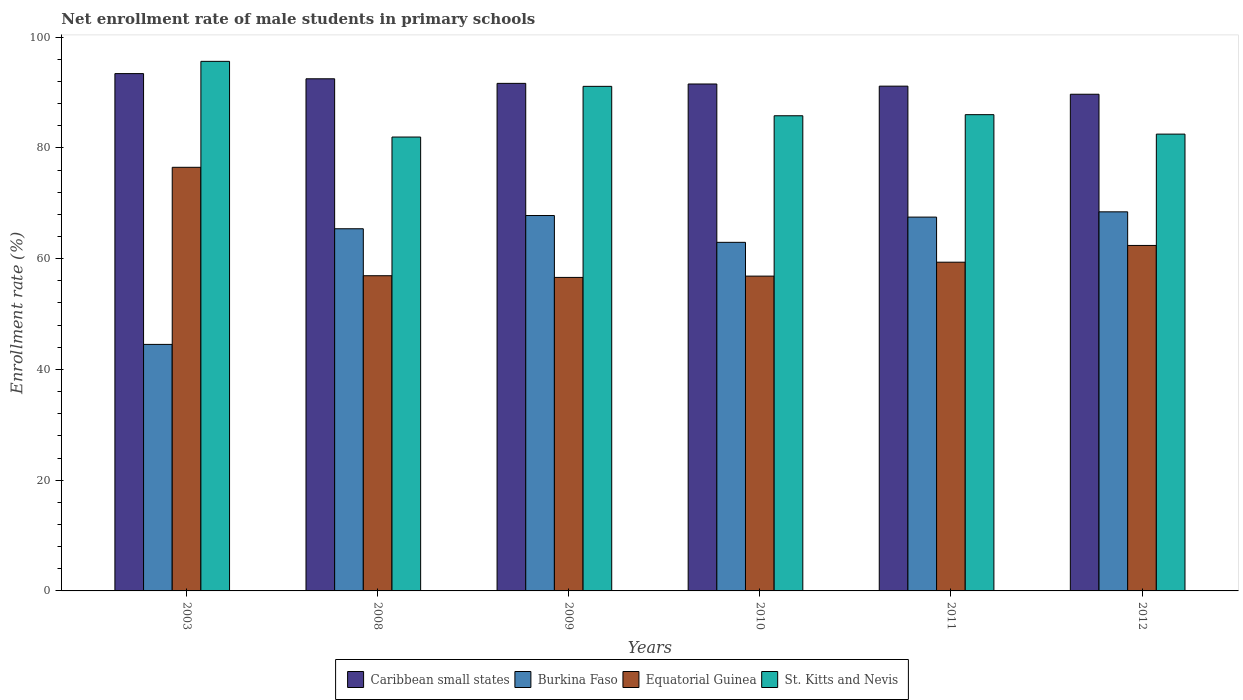How many groups of bars are there?
Offer a terse response. 6. Are the number of bars per tick equal to the number of legend labels?
Keep it short and to the point. Yes. How many bars are there on the 5th tick from the right?
Your answer should be compact. 4. What is the net enrollment rate of male students in primary schools in Caribbean small states in 2012?
Make the answer very short. 89.69. Across all years, what is the maximum net enrollment rate of male students in primary schools in Caribbean small states?
Keep it short and to the point. 93.42. Across all years, what is the minimum net enrollment rate of male students in primary schools in Burkina Faso?
Keep it short and to the point. 44.52. In which year was the net enrollment rate of male students in primary schools in Equatorial Guinea maximum?
Your response must be concise. 2003. In which year was the net enrollment rate of male students in primary schools in Caribbean small states minimum?
Offer a terse response. 2012. What is the total net enrollment rate of male students in primary schools in St. Kitts and Nevis in the graph?
Offer a terse response. 523. What is the difference between the net enrollment rate of male students in primary schools in Caribbean small states in 2003 and that in 2008?
Offer a very short reply. 0.94. What is the difference between the net enrollment rate of male students in primary schools in Caribbean small states in 2008 and the net enrollment rate of male students in primary schools in Burkina Faso in 2010?
Your answer should be very brief. 29.53. What is the average net enrollment rate of male students in primary schools in St. Kitts and Nevis per year?
Offer a terse response. 87.17. In the year 2009, what is the difference between the net enrollment rate of male students in primary schools in Equatorial Guinea and net enrollment rate of male students in primary schools in Caribbean small states?
Provide a short and direct response. -35.04. What is the ratio of the net enrollment rate of male students in primary schools in Caribbean small states in 2003 to that in 2010?
Offer a terse response. 1.02. Is the difference between the net enrollment rate of male students in primary schools in Equatorial Guinea in 2009 and 2012 greater than the difference between the net enrollment rate of male students in primary schools in Caribbean small states in 2009 and 2012?
Provide a succinct answer. No. What is the difference between the highest and the second highest net enrollment rate of male students in primary schools in Caribbean small states?
Your answer should be very brief. 0.94. What is the difference between the highest and the lowest net enrollment rate of male students in primary schools in Caribbean small states?
Your answer should be compact. 3.73. In how many years, is the net enrollment rate of male students in primary schools in Caribbean small states greater than the average net enrollment rate of male students in primary schools in Caribbean small states taken over all years?
Ensure brevity in your answer.  2. What does the 1st bar from the left in 2003 represents?
Ensure brevity in your answer.  Caribbean small states. What does the 1st bar from the right in 2012 represents?
Your response must be concise. St. Kitts and Nevis. Is it the case that in every year, the sum of the net enrollment rate of male students in primary schools in Caribbean small states and net enrollment rate of male students in primary schools in Burkina Faso is greater than the net enrollment rate of male students in primary schools in Equatorial Guinea?
Provide a succinct answer. Yes. Are all the bars in the graph horizontal?
Your answer should be compact. No. What is the difference between two consecutive major ticks on the Y-axis?
Keep it short and to the point. 20. Are the values on the major ticks of Y-axis written in scientific E-notation?
Keep it short and to the point. No. How many legend labels are there?
Provide a succinct answer. 4. How are the legend labels stacked?
Provide a succinct answer. Horizontal. What is the title of the graph?
Ensure brevity in your answer.  Net enrollment rate of male students in primary schools. Does "Belarus" appear as one of the legend labels in the graph?
Give a very brief answer. No. What is the label or title of the Y-axis?
Make the answer very short. Enrollment rate (%). What is the Enrollment rate (%) of Caribbean small states in 2003?
Offer a terse response. 93.42. What is the Enrollment rate (%) in Burkina Faso in 2003?
Provide a succinct answer. 44.52. What is the Enrollment rate (%) of Equatorial Guinea in 2003?
Your answer should be compact. 76.5. What is the Enrollment rate (%) in St. Kitts and Nevis in 2003?
Provide a succinct answer. 95.63. What is the Enrollment rate (%) of Caribbean small states in 2008?
Give a very brief answer. 92.48. What is the Enrollment rate (%) of Burkina Faso in 2008?
Give a very brief answer. 65.4. What is the Enrollment rate (%) in Equatorial Guinea in 2008?
Your answer should be compact. 56.92. What is the Enrollment rate (%) of St. Kitts and Nevis in 2008?
Provide a succinct answer. 81.96. What is the Enrollment rate (%) of Caribbean small states in 2009?
Provide a succinct answer. 91.65. What is the Enrollment rate (%) of Burkina Faso in 2009?
Provide a short and direct response. 67.79. What is the Enrollment rate (%) in Equatorial Guinea in 2009?
Offer a terse response. 56.61. What is the Enrollment rate (%) in St. Kitts and Nevis in 2009?
Give a very brief answer. 91.12. What is the Enrollment rate (%) of Caribbean small states in 2010?
Offer a terse response. 91.54. What is the Enrollment rate (%) of Burkina Faso in 2010?
Your answer should be compact. 62.95. What is the Enrollment rate (%) of Equatorial Guinea in 2010?
Provide a short and direct response. 56.85. What is the Enrollment rate (%) in St. Kitts and Nevis in 2010?
Offer a terse response. 85.8. What is the Enrollment rate (%) of Caribbean small states in 2011?
Your answer should be very brief. 91.15. What is the Enrollment rate (%) in Burkina Faso in 2011?
Keep it short and to the point. 67.5. What is the Enrollment rate (%) of Equatorial Guinea in 2011?
Offer a very short reply. 59.36. What is the Enrollment rate (%) of St. Kitts and Nevis in 2011?
Offer a very short reply. 86. What is the Enrollment rate (%) of Caribbean small states in 2012?
Ensure brevity in your answer.  89.69. What is the Enrollment rate (%) in Burkina Faso in 2012?
Offer a very short reply. 68.46. What is the Enrollment rate (%) in Equatorial Guinea in 2012?
Your response must be concise. 62.39. What is the Enrollment rate (%) in St. Kitts and Nevis in 2012?
Your answer should be compact. 82.49. Across all years, what is the maximum Enrollment rate (%) of Caribbean small states?
Your answer should be very brief. 93.42. Across all years, what is the maximum Enrollment rate (%) in Burkina Faso?
Ensure brevity in your answer.  68.46. Across all years, what is the maximum Enrollment rate (%) of Equatorial Guinea?
Provide a succinct answer. 76.5. Across all years, what is the maximum Enrollment rate (%) in St. Kitts and Nevis?
Your answer should be compact. 95.63. Across all years, what is the minimum Enrollment rate (%) of Caribbean small states?
Your answer should be very brief. 89.69. Across all years, what is the minimum Enrollment rate (%) of Burkina Faso?
Offer a very short reply. 44.52. Across all years, what is the minimum Enrollment rate (%) in Equatorial Guinea?
Your answer should be very brief. 56.61. Across all years, what is the minimum Enrollment rate (%) in St. Kitts and Nevis?
Offer a very short reply. 81.96. What is the total Enrollment rate (%) in Caribbean small states in the graph?
Make the answer very short. 549.93. What is the total Enrollment rate (%) of Burkina Faso in the graph?
Your answer should be very brief. 376.61. What is the total Enrollment rate (%) of Equatorial Guinea in the graph?
Keep it short and to the point. 368.62. What is the total Enrollment rate (%) of St. Kitts and Nevis in the graph?
Keep it short and to the point. 523. What is the difference between the Enrollment rate (%) in Caribbean small states in 2003 and that in 2008?
Offer a terse response. 0.94. What is the difference between the Enrollment rate (%) in Burkina Faso in 2003 and that in 2008?
Keep it short and to the point. -20.88. What is the difference between the Enrollment rate (%) of Equatorial Guinea in 2003 and that in 2008?
Your answer should be very brief. 19.58. What is the difference between the Enrollment rate (%) of St. Kitts and Nevis in 2003 and that in 2008?
Offer a very short reply. 13.67. What is the difference between the Enrollment rate (%) in Caribbean small states in 2003 and that in 2009?
Ensure brevity in your answer.  1.76. What is the difference between the Enrollment rate (%) in Burkina Faso in 2003 and that in 2009?
Ensure brevity in your answer.  -23.27. What is the difference between the Enrollment rate (%) in Equatorial Guinea in 2003 and that in 2009?
Your response must be concise. 19.89. What is the difference between the Enrollment rate (%) of St. Kitts and Nevis in 2003 and that in 2009?
Give a very brief answer. 4.51. What is the difference between the Enrollment rate (%) of Caribbean small states in 2003 and that in 2010?
Offer a terse response. 1.88. What is the difference between the Enrollment rate (%) of Burkina Faso in 2003 and that in 2010?
Your answer should be very brief. -18.43. What is the difference between the Enrollment rate (%) of Equatorial Guinea in 2003 and that in 2010?
Provide a succinct answer. 19.65. What is the difference between the Enrollment rate (%) of St. Kitts and Nevis in 2003 and that in 2010?
Your answer should be compact. 9.83. What is the difference between the Enrollment rate (%) of Caribbean small states in 2003 and that in 2011?
Your answer should be very brief. 2.27. What is the difference between the Enrollment rate (%) of Burkina Faso in 2003 and that in 2011?
Keep it short and to the point. -22.99. What is the difference between the Enrollment rate (%) of Equatorial Guinea in 2003 and that in 2011?
Offer a very short reply. 17.14. What is the difference between the Enrollment rate (%) in St. Kitts and Nevis in 2003 and that in 2011?
Your response must be concise. 9.63. What is the difference between the Enrollment rate (%) of Caribbean small states in 2003 and that in 2012?
Give a very brief answer. 3.73. What is the difference between the Enrollment rate (%) of Burkina Faso in 2003 and that in 2012?
Your answer should be compact. -23.94. What is the difference between the Enrollment rate (%) of Equatorial Guinea in 2003 and that in 2012?
Offer a terse response. 14.11. What is the difference between the Enrollment rate (%) of St. Kitts and Nevis in 2003 and that in 2012?
Offer a very short reply. 13.14. What is the difference between the Enrollment rate (%) of Caribbean small states in 2008 and that in 2009?
Keep it short and to the point. 0.83. What is the difference between the Enrollment rate (%) in Burkina Faso in 2008 and that in 2009?
Keep it short and to the point. -2.39. What is the difference between the Enrollment rate (%) of Equatorial Guinea in 2008 and that in 2009?
Ensure brevity in your answer.  0.31. What is the difference between the Enrollment rate (%) of St. Kitts and Nevis in 2008 and that in 2009?
Ensure brevity in your answer.  -9.15. What is the difference between the Enrollment rate (%) of Burkina Faso in 2008 and that in 2010?
Ensure brevity in your answer.  2.45. What is the difference between the Enrollment rate (%) of Equatorial Guinea in 2008 and that in 2010?
Give a very brief answer. 0.07. What is the difference between the Enrollment rate (%) of St. Kitts and Nevis in 2008 and that in 2010?
Your answer should be compact. -3.84. What is the difference between the Enrollment rate (%) in Caribbean small states in 2008 and that in 2011?
Your response must be concise. 1.33. What is the difference between the Enrollment rate (%) of Burkina Faso in 2008 and that in 2011?
Your answer should be very brief. -2.1. What is the difference between the Enrollment rate (%) of Equatorial Guinea in 2008 and that in 2011?
Offer a terse response. -2.44. What is the difference between the Enrollment rate (%) of St. Kitts and Nevis in 2008 and that in 2011?
Offer a terse response. -4.04. What is the difference between the Enrollment rate (%) in Caribbean small states in 2008 and that in 2012?
Offer a very short reply. 2.79. What is the difference between the Enrollment rate (%) of Burkina Faso in 2008 and that in 2012?
Offer a very short reply. -3.06. What is the difference between the Enrollment rate (%) in Equatorial Guinea in 2008 and that in 2012?
Make the answer very short. -5.47. What is the difference between the Enrollment rate (%) in St. Kitts and Nevis in 2008 and that in 2012?
Keep it short and to the point. -0.53. What is the difference between the Enrollment rate (%) in Caribbean small states in 2009 and that in 2010?
Give a very brief answer. 0.11. What is the difference between the Enrollment rate (%) in Burkina Faso in 2009 and that in 2010?
Offer a very short reply. 4.84. What is the difference between the Enrollment rate (%) in Equatorial Guinea in 2009 and that in 2010?
Ensure brevity in your answer.  -0.23. What is the difference between the Enrollment rate (%) of St. Kitts and Nevis in 2009 and that in 2010?
Provide a short and direct response. 5.31. What is the difference between the Enrollment rate (%) of Caribbean small states in 2009 and that in 2011?
Your response must be concise. 0.5. What is the difference between the Enrollment rate (%) in Burkina Faso in 2009 and that in 2011?
Provide a succinct answer. 0.28. What is the difference between the Enrollment rate (%) of Equatorial Guinea in 2009 and that in 2011?
Give a very brief answer. -2.75. What is the difference between the Enrollment rate (%) in St. Kitts and Nevis in 2009 and that in 2011?
Provide a short and direct response. 5.11. What is the difference between the Enrollment rate (%) of Caribbean small states in 2009 and that in 2012?
Your answer should be very brief. 1.96. What is the difference between the Enrollment rate (%) of Burkina Faso in 2009 and that in 2012?
Provide a short and direct response. -0.67. What is the difference between the Enrollment rate (%) in Equatorial Guinea in 2009 and that in 2012?
Keep it short and to the point. -5.77. What is the difference between the Enrollment rate (%) of St. Kitts and Nevis in 2009 and that in 2012?
Make the answer very short. 8.63. What is the difference between the Enrollment rate (%) in Caribbean small states in 2010 and that in 2011?
Your response must be concise. 0.39. What is the difference between the Enrollment rate (%) of Burkina Faso in 2010 and that in 2011?
Provide a succinct answer. -4.56. What is the difference between the Enrollment rate (%) in Equatorial Guinea in 2010 and that in 2011?
Offer a terse response. -2.52. What is the difference between the Enrollment rate (%) of St. Kitts and Nevis in 2010 and that in 2011?
Provide a short and direct response. -0.2. What is the difference between the Enrollment rate (%) in Caribbean small states in 2010 and that in 2012?
Offer a terse response. 1.85. What is the difference between the Enrollment rate (%) of Burkina Faso in 2010 and that in 2012?
Your answer should be compact. -5.51. What is the difference between the Enrollment rate (%) in Equatorial Guinea in 2010 and that in 2012?
Provide a succinct answer. -5.54. What is the difference between the Enrollment rate (%) in St. Kitts and Nevis in 2010 and that in 2012?
Make the answer very short. 3.31. What is the difference between the Enrollment rate (%) of Caribbean small states in 2011 and that in 2012?
Provide a short and direct response. 1.46. What is the difference between the Enrollment rate (%) of Burkina Faso in 2011 and that in 2012?
Give a very brief answer. -0.95. What is the difference between the Enrollment rate (%) of Equatorial Guinea in 2011 and that in 2012?
Ensure brevity in your answer.  -3.02. What is the difference between the Enrollment rate (%) in St. Kitts and Nevis in 2011 and that in 2012?
Your response must be concise. 3.51. What is the difference between the Enrollment rate (%) in Caribbean small states in 2003 and the Enrollment rate (%) in Burkina Faso in 2008?
Make the answer very short. 28.02. What is the difference between the Enrollment rate (%) of Caribbean small states in 2003 and the Enrollment rate (%) of Equatorial Guinea in 2008?
Provide a short and direct response. 36.5. What is the difference between the Enrollment rate (%) in Caribbean small states in 2003 and the Enrollment rate (%) in St. Kitts and Nevis in 2008?
Keep it short and to the point. 11.46. What is the difference between the Enrollment rate (%) in Burkina Faso in 2003 and the Enrollment rate (%) in Equatorial Guinea in 2008?
Give a very brief answer. -12.4. What is the difference between the Enrollment rate (%) in Burkina Faso in 2003 and the Enrollment rate (%) in St. Kitts and Nevis in 2008?
Your answer should be compact. -37.44. What is the difference between the Enrollment rate (%) in Equatorial Guinea in 2003 and the Enrollment rate (%) in St. Kitts and Nevis in 2008?
Your response must be concise. -5.46. What is the difference between the Enrollment rate (%) of Caribbean small states in 2003 and the Enrollment rate (%) of Burkina Faso in 2009?
Ensure brevity in your answer.  25.63. What is the difference between the Enrollment rate (%) in Caribbean small states in 2003 and the Enrollment rate (%) in Equatorial Guinea in 2009?
Your answer should be compact. 36.81. What is the difference between the Enrollment rate (%) in Caribbean small states in 2003 and the Enrollment rate (%) in St. Kitts and Nevis in 2009?
Provide a succinct answer. 2.3. What is the difference between the Enrollment rate (%) in Burkina Faso in 2003 and the Enrollment rate (%) in Equatorial Guinea in 2009?
Ensure brevity in your answer.  -12.1. What is the difference between the Enrollment rate (%) of Burkina Faso in 2003 and the Enrollment rate (%) of St. Kitts and Nevis in 2009?
Provide a succinct answer. -46.6. What is the difference between the Enrollment rate (%) in Equatorial Guinea in 2003 and the Enrollment rate (%) in St. Kitts and Nevis in 2009?
Offer a very short reply. -14.62. What is the difference between the Enrollment rate (%) in Caribbean small states in 2003 and the Enrollment rate (%) in Burkina Faso in 2010?
Provide a short and direct response. 30.47. What is the difference between the Enrollment rate (%) of Caribbean small states in 2003 and the Enrollment rate (%) of Equatorial Guinea in 2010?
Provide a short and direct response. 36.57. What is the difference between the Enrollment rate (%) in Caribbean small states in 2003 and the Enrollment rate (%) in St. Kitts and Nevis in 2010?
Offer a terse response. 7.61. What is the difference between the Enrollment rate (%) in Burkina Faso in 2003 and the Enrollment rate (%) in Equatorial Guinea in 2010?
Make the answer very short. -12.33. What is the difference between the Enrollment rate (%) in Burkina Faso in 2003 and the Enrollment rate (%) in St. Kitts and Nevis in 2010?
Give a very brief answer. -41.29. What is the difference between the Enrollment rate (%) of Equatorial Guinea in 2003 and the Enrollment rate (%) of St. Kitts and Nevis in 2010?
Make the answer very short. -9.31. What is the difference between the Enrollment rate (%) of Caribbean small states in 2003 and the Enrollment rate (%) of Burkina Faso in 2011?
Give a very brief answer. 25.91. What is the difference between the Enrollment rate (%) in Caribbean small states in 2003 and the Enrollment rate (%) in Equatorial Guinea in 2011?
Your answer should be compact. 34.06. What is the difference between the Enrollment rate (%) of Caribbean small states in 2003 and the Enrollment rate (%) of St. Kitts and Nevis in 2011?
Ensure brevity in your answer.  7.41. What is the difference between the Enrollment rate (%) of Burkina Faso in 2003 and the Enrollment rate (%) of Equatorial Guinea in 2011?
Ensure brevity in your answer.  -14.85. What is the difference between the Enrollment rate (%) of Burkina Faso in 2003 and the Enrollment rate (%) of St. Kitts and Nevis in 2011?
Give a very brief answer. -41.49. What is the difference between the Enrollment rate (%) in Equatorial Guinea in 2003 and the Enrollment rate (%) in St. Kitts and Nevis in 2011?
Your answer should be compact. -9.51. What is the difference between the Enrollment rate (%) in Caribbean small states in 2003 and the Enrollment rate (%) in Burkina Faso in 2012?
Your response must be concise. 24.96. What is the difference between the Enrollment rate (%) of Caribbean small states in 2003 and the Enrollment rate (%) of Equatorial Guinea in 2012?
Offer a very short reply. 31.03. What is the difference between the Enrollment rate (%) in Caribbean small states in 2003 and the Enrollment rate (%) in St. Kitts and Nevis in 2012?
Make the answer very short. 10.93. What is the difference between the Enrollment rate (%) of Burkina Faso in 2003 and the Enrollment rate (%) of Equatorial Guinea in 2012?
Ensure brevity in your answer.  -17.87. What is the difference between the Enrollment rate (%) in Burkina Faso in 2003 and the Enrollment rate (%) in St. Kitts and Nevis in 2012?
Make the answer very short. -37.97. What is the difference between the Enrollment rate (%) in Equatorial Guinea in 2003 and the Enrollment rate (%) in St. Kitts and Nevis in 2012?
Ensure brevity in your answer.  -5.99. What is the difference between the Enrollment rate (%) of Caribbean small states in 2008 and the Enrollment rate (%) of Burkina Faso in 2009?
Your answer should be very brief. 24.69. What is the difference between the Enrollment rate (%) in Caribbean small states in 2008 and the Enrollment rate (%) in Equatorial Guinea in 2009?
Your response must be concise. 35.87. What is the difference between the Enrollment rate (%) of Caribbean small states in 2008 and the Enrollment rate (%) of St. Kitts and Nevis in 2009?
Ensure brevity in your answer.  1.37. What is the difference between the Enrollment rate (%) of Burkina Faso in 2008 and the Enrollment rate (%) of Equatorial Guinea in 2009?
Your answer should be very brief. 8.79. What is the difference between the Enrollment rate (%) in Burkina Faso in 2008 and the Enrollment rate (%) in St. Kitts and Nevis in 2009?
Your response must be concise. -25.71. What is the difference between the Enrollment rate (%) in Equatorial Guinea in 2008 and the Enrollment rate (%) in St. Kitts and Nevis in 2009?
Your answer should be compact. -34.2. What is the difference between the Enrollment rate (%) in Caribbean small states in 2008 and the Enrollment rate (%) in Burkina Faso in 2010?
Your response must be concise. 29.53. What is the difference between the Enrollment rate (%) of Caribbean small states in 2008 and the Enrollment rate (%) of Equatorial Guinea in 2010?
Provide a succinct answer. 35.64. What is the difference between the Enrollment rate (%) of Caribbean small states in 2008 and the Enrollment rate (%) of St. Kitts and Nevis in 2010?
Make the answer very short. 6.68. What is the difference between the Enrollment rate (%) of Burkina Faso in 2008 and the Enrollment rate (%) of Equatorial Guinea in 2010?
Your response must be concise. 8.55. What is the difference between the Enrollment rate (%) of Burkina Faso in 2008 and the Enrollment rate (%) of St. Kitts and Nevis in 2010?
Offer a terse response. -20.4. What is the difference between the Enrollment rate (%) of Equatorial Guinea in 2008 and the Enrollment rate (%) of St. Kitts and Nevis in 2010?
Offer a terse response. -28.88. What is the difference between the Enrollment rate (%) of Caribbean small states in 2008 and the Enrollment rate (%) of Burkina Faso in 2011?
Offer a terse response. 24.98. What is the difference between the Enrollment rate (%) in Caribbean small states in 2008 and the Enrollment rate (%) in Equatorial Guinea in 2011?
Provide a succinct answer. 33.12. What is the difference between the Enrollment rate (%) in Caribbean small states in 2008 and the Enrollment rate (%) in St. Kitts and Nevis in 2011?
Your answer should be very brief. 6.48. What is the difference between the Enrollment rate (%) of Burkina Faso in 2008 and the Enrollment rate (%) of Equatorial Guinea in 2011?
Make the answer very short. 6.04. What is the difference between the Enrollment rate (%) in Burkina Faso in 2008 and the Enrollment rate (%) in St. Kitts and Nevis in 2011?
Your response must be concise. -20.6. What is the difference between the Enrollment rate (%) of Equatorial Guinea in 2008 and the Enrollment rate (%) of St. Kitts and Nevis in 2011?
Give a very brief answer. -29.08. What is the difference between the Enrollment rate (%) in Caribbean small states in 2008 and the Enrollment rate (%) in Burkina Faso in 2012?
Give a very brief answer. 24.03. What is the difference between the Enrollment rate (%) of Caribbean small states in 2008 and the Enrollment rate (%) of Equatorial Guinea in 2012?
Your answer should be compact. 30.1. What is the difference between the Enrollment rate (%) of Caribbean small states in 2008 and the Enrollment rate (%) of St. Kitts and Nevis in 2012?
Offer a very short reply. 9.99. What is the difference between the Enrollment rate (%) of Burkina Faso in 2008 and the Enrollment rate (%) of Equatorial Guinea in 2012?
Give a very brief answer. 3.01. What is the difference between the Enrollment rate (%) of Burkina Faso in 2008 and the Enrollment rate (%) of St. Kitts and Nevis in 2012?
Offer a very short reply. -17.09. What is the difference between the Enrollment rate (%) in Equatorial Guinea in 2008 and the Enrollment rate (%) in St. Kitts and Nevis in 2012?
Your answer should be very brief. -25.57. What is the difference between the Enrollment rate (%) in Caribbean small states in 2009 and the Enrollment rate (%) in Burkina Faso in 2010?
Keep it short and to the point. 28.71. What is the difference between the Enrollment rate (%) of Caribbean small states in 2009 and the Enrollment rate (%) of Equatorial Guinea in 2010?
Make the answer very short. 34.81. What is the difference between the Enrollment rate (%) in Caribbean small states in 2009 and the Enrollment rate (%) in St. Kitts and Nevis in 2010?
Your answer should be very brief. 5.85. What is the difference between the Enrollment rate (%) of Burkina Faso in 2009 and the Enrollment rate (%) of Equatorial Guinea in 2010?
Give a very brief answer. 10.94. What is the difference between the Enrollment rate (%) of Burkina Faso in 2009 and the Enrollment rate (%) of St. Kitts and Nevis in 2010?
Offer a very short reply. -18.01. What is the difference between the Enrollment rate (%) of Equatorial Guinea in 2009 and the Enrollment rate (%) of St. Kitts and Nevis in 2010?
Ensure brevity in your answer.  -29.19. What is the difference between the Enrollment rate (%) in Caribbean small states in 2009 and the Enrollment rate (%) in Burkina Faso in 2011?
Give a very brief answer. 24.15. What is the difference between the Enrollment rate (%) of Caribbean small states in 2009 and the Enrollment rate (%) of Equatorial Guinea in 2011?
Keep it short and to the point. 32.29. What is the difference between the Enrollment rate (%) in Caribbean small states in 2009 and the Enrollment rate (%) in St. Kitts and Nevis in 2011?
Offer a terse response. 5.65. What is the difference between the Enrollment rate (%) in Burkina Faso in 2009 and the Enrollment rate (%) in Equatorial Guinea in 2011?
Your answer should be compact. 8.43. What is the difference between the Enrollment rate (%) in Burkina Faso in 2009 and the Enrollment rate (%) in St. Kitts and Nevis in 2011?
Keep it short and to the point. -18.21. What is the difference between the Enrollment rate (%) of Equatorial Guinea in 2009 and the Enrollment rate (%) of St. Kitts and Nevis in 2011?
Your response must be concise. -29.39. What is the difference between the Enrollment rate (%) in Caribbean small states in 2009 and the Enrollment rate (%) in Burkina Faso in 2012?
Your answer should be compact. 23.2. What is the difference between the Enrollment rate (%) in Caribbean small states in 2009 and the Enrollment rate (%) in Equatorial Guinea in 2012?
Provide a short and direct response. 29.27. What is the difference between the Enrollment rate (%) of Caribbean small states in 2009 and the Enrollment rate (%) of St. Kitts and Nevis in 2012?
Keep it short and to the point. 9.17. What is the difference between the Enrollment rate (%) in Burkina Faso in 2009 and the Enrollment rate (%) in Equatorial Guinea in 2012?
Keep it short and to the point. 5.4. What is the difference between the Enrollment rate (%) in Burkina Faso in 2009 and the Enrollment rate (%) in St. Kitts and Nevis in 2012?
Offer a terse response. -14.7. What is the difference between the Enrollment rate (%) of Equatorial Guinea in 2009 and the Enrollment rate (%) of St. Kitts and Nevis in 2012?
Your answer should be compact. -25.88. What is the difference between the Enrollment rate (%) of Caribbean small states in 2010 and the Enrollment rate (%) of Burkina Faso in 2011?
Ensure brevity in your answer.  24.04. What is the difference between the Enrollment rate (%) of Caribbean small states in 2010 and the Enrollment rate (%) of Equatorial Guinea in 2011?
Give a very brief answer. 32.18. What is the difference between the Enrollment rate (%) of Caribbean small states in 2010 and the Enrollment rate (%) of St. Kitts and Nevis in 2011?
Make the answer very short. 5.54. What is the difference between the Enrollment rate (%) of Burkina Faso in 2010 and the Enrollment rate (%) of Equatorial Guinea in 2011?
Your answer should be very brief. 3.59. What is the difference between the Enrollment rate (%) in Burkina Faso in 2010 and the Enrollment rate (%) in St. Kitts and Nevis in 2011?
Offer a terse response. -23.05. What is the difference between the Enrollment rate (%) of Equatorial Guinea in 2010 and the Enrollment rate (%) of St. Kitts and Nevis in 2011?
Your answer should be very brief. -29.16. What is the difference between the Enrollment rate (%) in Caribbean small states in 2010 and the Enrollment rate (%) in Burkina Faso in 2012?
Offer a terse response. 23.09. What is the difference between the Enrollment rate (%) of Caribbean small states in 2010 and the Enrollment rate (%) of Equatorial Guinea in 2012?
Give a very brief answer. 29.16. What is the difference between the Enrollment rate (%) in Caribbean small states in 2010 and the Enrollment rate (%) in St. Kitts and Nevis in 2012?
Provide a short and direct response. 9.05. What is the difference between the Enrollment rate (%) in Burkina Faso in 2010 and the Enrollment rate (%) in Equatorial Guinea in 2012?
Provide a short and direct response. 0.56. What is the difference between the Enrollment rate (%) in Burkina Faso in 2010 and the Enrollment rate (%) in St. Kitts and Nevis in 2012?
Keep it short and to the point. -19.54. What is the difference between the Enrollment rate (%) of Equatorial Guinea in 2010 and the Enrollment rate (%) of St. Kitts and Nevis in 2012?
Provide a succinct answer. -25.64. What is the difference between the Enrollment rate (%) in Caribbean small states in 2011 and the Enrollment rate (%) in Burkina Faso in 2012?
Your response must be concise. 22.7. What is the difference between the Enrollment rate (%) of Caribbean small states in 2011 and the Enrollment rate (%) of Equatorial Guinea in 2012?
Give a very brief answer. 28.77. What is the difference between the Enrollment rate (%) in Caribbean small states in 2011 and the Enrollment rate (%) in St. Kitts and Nevis in 2012?
Ensure brevity in your answer.  8.66. What is the difference between the Enrollment rate (%) in Burkina Faso in 2011 and the Enrollment rate (%) in Equatorial Guinea in 2012?
Your response must be concise. 5.12. What is the difference between the Enrollment rate (%) in Burkina Faso in 2011 and the Enrollment rate (%) in St. Kitts and Nevis in 2012?
Offer a very short reply. -14.98. What is the difference between the Enrollment rate (%) of Equatorial Guinea in 2011 and the Enrollment rate (%) of St. Kitts and Nevis in 2012?
Your answer should be very brief. -23.13. What is the average Enrollment rate (%) of Caribbean small states per year?
Give a very brief answer. 91.66. What is the average Enrollment rate (%) in Burkina Faso per year?
Provide a short and direct response. 62.77. What is the average Enrollment rate (%) of Equatorial Guinea per year?
Your response must be concise. 61.44. What is the average Enrollment rate (%) in St. Kitts and Nevis per year?
Your answer should be compact. 87.17. In the year 2003, what is the difference between the Enrollment rate (%) of Caribbean small states and Enrollment rate (%) of Burkina Faso?
Offer a very short reply. 48.9. In the year 2003, what is the difference between the Enrollment rate (%) in Caribbean small states and Enrollment rate (%) in Equatorial Guinea?
Make the answer very short. 16.92. In the year 2003, what is the difference between the Enrollment rate (%) of Caribbean small states and Enrollment rate (%) of St. Kitts and Nevis?
Offer a terse response. -2.21. In the year 2003, what is the difference between the Enrollment rate (%) of Burkina Faso and Enrollment rate (%) of Equatorial Guinea?
Offer a terse response. -31.98. In the year 2003, what is the difference between the Enrollment rate (%) in Burkina Faso and Enrollment rate (%) in St. Kitts and Nevis?
Offer a very short reply. -51.11. In the year 2003, what is the difference between the Enrollment rate (%) in Equatorial Guinea and Enrollment rate (%) in St. Kitts and Nevis?
Make the answer very short. -19.13. In the year 2008, what is the difference between the Enrollment rate (%) in Caribbean small states and Enrollment rate (%) in Burkina Faso?
Your response must be concise. 27.08. In the year 2008, what is the difference between the Enrollment rate (%) of Caribbean small states and Enrollment rate (%) of Equatorial Guinea?
Your answer should be compact. 35.56. In the year 2008, what is the difference between the Enrollment rate (%) of Caribbean small states and Enrollment rate (%) of St. Kitts and Nevis?
Provide a short and direct response. 10.52. In the year 2008, what is the difference between the Enrollment rate (%) of Burkina Faso and Enrollment rate (%) of Equatorial Guinea?
Provide a short and direct response. 8.48. In the year 2008, what is the difference between the Enrollment rate (%) of Burkina Faso and Enrollment rate (%) of St. Kitts and Nevis?
Make the answer very short. -16.56. In the year 2008, what is the difference between the Enrollment rate (%) in Equatorial Guinea and Enrollment rate (%) in St. Kitts and Nevis?
Give a very brief answer. -25.04. In the year 2009, what is the difference between the Enrollment rate (%) in Caribbean small states and Enrollment rate (%) in Burkina Faso?
Keep it short and to the point. 23.86. In the year 2009, what is the difference between the Enrollment rate (%) of Caribbean small states and Enrollment rate (%) of Equatorial Guinea?
Give a very brief answer. 35.04. In the year 2009, what is the difference between the Enrollment rate (%) of Caribbean small states and Enrollment rate (%) of St. Kitts and Nevis?
Give a very brief answer. 0.54. In the year 2009, what is the difference between the Enrollment rate (%) of Burkina Faso and Enrollment rate (%) of Equatorial Guinea?
Your response must be concise. 11.18. In the year 2009, what is the difference between the Enrollment rate (%) of Burkina Faso and Enrollment rate (%) of St. Kitts and Nevis?
Make the answer very short. -23.33. In the year 2009, what is the difference between the Enrollment rate (%) of Equatorial Guinea and Enrollment rate (%) of St. Kitts and Nevis?
Provide a short and direct response. -34.5. In the year 2010, what is the difference between the Enrollment rate (%) in Caribbean small states and Enrollment rate (%) in Burkina Faso?
Make the answer very short. 28.59. In the year 2010, what is the difference between the Enrollment rate (%) of Caribbean small states and Enrollment rate (%) of Equatorial Guinea?
Give a very brief answer. 34.7. In the year 2010, what is the difference between the Enrollment rate (%) of Caribbean small states and Enrollment rate (%) of St. Kitts and Nevis?
Provide a short and direct response. 5.74. In the year 2010, what is the difference between the Enrollment rate (%) of Burkina Faso and Enrollment rate (%) of Equatorial Guinea?
Provide a succinct answer. 6.1. In the year 2010, what is the difference between the Enrollment rate (%) of Burkina Faso and Enrollment rate (%) of St. Kitts and Nevis?
Offer a very short reply. -22.85. In the year 2010, what is the difference between the Enrollment rate (%) in Equatorial Guinea and Enrollment rate (%) in St. Kitts and Nevis?
Provide a succinct answer. -28.96. In the year 2011, what is the difference between the Enrollment rate (%) in Caribbean small states and Enrollment rate (%) in Burkina Faso?
Provide a short and direct response. 23.65. In the year 2011, what is the difference between the Enrollment rate (%) of Caribbean small states and Enrollment rate (%) of Equatorial Guinea?
Your response must be concise. 31.79. In the year 2011, what is the difference between the Enrollment rate (%) of Caribbean small states and Enrollment rate (%) of St. Kitts and Nevis?
Ensure brevity in your answer.  5.15. In the year 2011, what is the difference between the Enrollment rate (%) of Burkina Faso and Enrollment rate (%) of Equatorial Guinea?
Provide a succinct answer. 8.14. In the year 2011, what is the difference between the Enrollment rate (%) in Burkina Faso and Enrollment rate (%) in St. Kitts and Nevis?
Give a very brief answer. -18.5. In the year 2011, what is the difference between the Enrollment rate (%) of Equatorial Guinea and Enrollment rate (%) of St. Kitts and Nevis?
Offer a terse response. -26.64. In the year 2012, what is the difference between the Enrollment rate (%) in Caribbean small states and Enrollment rate (%) in Burkina Faso?
Offer a very short reply. 21.23. In the year 2012, what is the difference between the Enrollment rate (%) in Caribbean small states and Enrollment rate (%) in Equatorial Guinea?
Provide a succinct answer. 27.3. In the year 2012, what is the difference between the Enrollment rate (%) in Caribbean small states and Enrollment rate (%) in St. Kitts and Nevis?
Ensure brevity in your answer.  7.2. In the year 2012, what is the difference between the Enrollment rate (%) of Burkina Faso and Enrollment rate (%) of Equatorial Guinea?
Make the answer very short. 6.07. In the year 2012, what is the difference between the Enrollment rate (%) of Burkina Faso and Enrollment rate (%) of St. Kitts and Nevis?
Provide a succinct answer. -14.03. In the year 2012, what is the difference between the Enrollment rate (%) of Equatorial Guinea and Enrollment rate (%) of St. Kitts and Nevis?
Offer a terse response. -20.1. What is the ratio of the Enrollment rate (%) of Burkina Faso in 2003 to that in 2008?
Ensure brevity in your answer.  0.68. What is the ratio of the Enrollment rate (%) of Equatorial Guinea in 2003 to that in 2008?
Offer a terse response. 1.34. What is the ratio of the Enrollment rate (%) of St. Kitts and Nevis in 2003 to that in 2008?
Make the answer very short. 1.17. What is the ratio of the Enrollment rate (%) in Caribbean small states in 2003 to that in 2009?
Your answer should be very brief. 1.02. What is the ratio of the Enrollment rate (%) of Burkina Faso in 2003 to that in 2009?
Give a very brief answer. 0.66. What is the ratio of the Enrollment rate (%) of Equatorial Guinea in 2003 to that in 2009?
Provide a short and direct response. 1.35. What is the ratio of the Enrollment rate (%) of St. Kitts and Nevis in 2003 to that in 2009?
Your answer should be compact. 1.05. What is the ratio of the Enrollment rate (%) in Caribbean small states in 2003 to that in 2010?
Your answer should be very brief. 1.02. What is the ratio of the Enrollment rate (%) in Burkina Faso in 2003 to that in 2010?
Ensure brevity in your answer.  0.71. What is the ratio of the Enrollment rate (%) of Equatorial Guinea in 2003 to that in 2010?
Keep it short and to the point. 1.35. What is the ratio of the Enrollment rate (%) of St. Kitts and Nevis in 2003 to that in 2010?
Give a very brief answer. 1.11. What is the ratio of the Enrollment rate (%) in Caribbean small states in 2003 to that in 2011?
Provide a succinct answer. 1.02. What is the ratio of the Enrollment rate (%) in Burkina Faso in 2003 to that in 2011?
Your response must be concise. 0.66. What is the ratio of the Enrollment rate (%) in Equatorial Guinea in 2003 to that in 2011?
Your answer should be very brief. 1.29. What is the ratio of the Enrollment rate (%) of St. Kitts and Nevis in 2003 to that in 2011?
Provide a succinct answer. 1.11. What is the ratio of the Enrollment rate (%) in Caribbean small states in 2003 to that in 2012?
Offer a terse response. 1.04. What is the ratio of the Enrollment rate (%) in Burkina Faso in 2003 to that in 2012?
Offer a very short reply. 0.65. What is the ratio of the Enrollment rate (%) in Equatorial Guinea in 2003 to that in 2012?
Offer a terse response. 1.23. What is the ratio of the Enrollment rate (%) in St. Kitts and Nevis in 2003 to that in 2012?
Your answer should be compact. 1.16. What is the ratio of the Enrollment rate (%) in Burkina Faso in 2008 to that in 2009?
Your answer should be compact. 0.96. What is the ratio of the Enrollment rate (%) in Equatorial Guinea in 2008 to that in 2009?
Keep it short and to the point. 1.01. What is the ratio of the Enrollment rate (%) of St. Kitts and Nevis in 2008 to that in 2009?
Provide a short and direct response. 0.9. What is the ratio of the Enrollment rate (%) of Caribbean small states in 2008 to that in 2010?
Your answer should be very brief. 1.01. What is the ratio of the Enrollment rate (%) in Burkina Faso in 2008 to that in 2010?
Provide a succinct answer. 1.04. What is the ratio of the Enrollment rate (%) in Equatorial Guinea in 2008 to that in 2010?
Keep it short and to the point. 1. What is the ratio of the Enrollment rate (%) of St. Kitts and Nevis in 2008 to that in 2010?
Make the answer very short. 0.96. What is the ratio of the Enrollment rate (%) in Caribbean small states in 2008 to that in 2011?
Ensure brevity in your answer.  1.01. What is the ratio of the Enrollment rate (%) of Burkina Faso in 2008 to that in 2011?
Keep it short and to the point. 0.97. What is the ratio of the Enrollment rate (%) of Equatorial Guinea in 2008 to that in 2011?
Ensure brevity in your answer.  0.96. What is the ratio of the Enrollment rate (%) of St. Kitts and Nevis in 2008 to that in 2011?
Make the answer very short. 0.95. What is the ratio of the Enrollment rate (%) in Caribbean small states in 2008 to that in 2012?
Offer a terse response. 1.03. What is the ratio of the Enrollment rate (%) in Burkina Faso in 2008 to that in 2012?
Your answer should be very brief. 0.96. What is the ratio of the Enrollment rate (%) of Equatorial Guinea in 2008 to that in 2012?
Your answer should be compact. 0.91. What is the ratio of the Enrollment rate (%) of Burkina Faso in 2009 to that in 2010?
Offer a very short reply. 1.08. What is the ratio of the Enrollment rate (%) of Equatorial Guinea in 2009 to that in 2010?
Offer a very short reply. 1. What is the ratio of the Enrollment rate (%) in St. Kitts and Nevis in 2009 to that in 2010?
Keep it short and to the point. 1.06. What is the ratio of the Enrollment rate (%) of Caribbean small states in 2009 to that in 2011?
Give a very brief answer. 1.01. What is the ratio of the Enrollment rate (%) of Burkina Faso in 2009 to that in 2011?
Keep it short and to the point. 1. What is the ratio of the Enrollment rate (%) of Equatorial Guinea in 2009 to that in 2011?
Your answer should be very brief. 0.95. What is the ratio of the Enrollment rate (%) of St. Kitts and Nevis in 2009 to that in 2011?
Make the answer very short. 1.06. What is the ratio of the Enrollment rate (%) of Caribbean small states in 2009 to that in 2012?
Your answer should be compact. 1.02. What is the ratio of the Enrollment rate (%) in Burkina Faso in 2009 to that in 2012?
Keep it short and to the point. 0.99. What is the ratio of the Enrollment rate (%) of Equatorial Guinea in 2009 to that in 2012?
Your response must be concise. 0.91. What is the ratio of the Enrollment rate (%) in St. Kitts and Nevis in 2009 to that in 2012?
Keep it short and to the point. 1.1. What is the ratio of the Enrollment rate (%) of Burkina Faso in 2010 to that in 2011?
Give a very brief answer. 0.93. What is the ratio of the Enrollment rate (%) in Equatorial Guinea in 2010 to that in 2011?
Your answer should be compact. 0.96. What is the ratio of the Enrollment rate (%) in St. Kitts and Nevis in 2010 to that in 2011?
Provide a succinct answer. 1. What is the ratio of the Enrollment rate (%) in Caribbean small states in 2010 to that in 2012?
Your answer should be very brief. 1.02. What is the ratio of the Enrollment rate (%) in Burkina Faso in 2010 to that in 2012?
Make the answer very short. 0.92. What is the ratio of the Enrollment rate (%) of Equatorial Guinea in 2010 to that in 2012?
Your answer should be very brief. 0.91. What is the ratio of the Enrollment rate (%) of St. Kitts and Nevis in 2010 to that in 2012?
Offer a terse response. 1.04. What is the ratio of the Enrollment rate (%) in Caribbean small states in 2011 to that in 2012?
Your answer should be compact. 1.02. What is the ratio of the Enrollment rate (%) of Burkina Faso in 2011 to that in 2012?
Make the answer very short. 0.99. What is the ratio of the Enrollment rate (%) in Equatorial Guinea in 2011 to that in 2012?
Offer a very short reply. 0.95. What is the ratio of the Enrollment rate (%) of St. Kitts and Nevis in 2011 to that in 2012?
Make the answer very short. 1.04. What is the difference between the highest and the second highest Enrollment rate (%) of Caribbean small states?
Your response must be concise. 0.94. What is the difference between the highest and the second highest Enrollment rate (%) in Burkina Faso?
Your answer should be very brief. 0.67. What is the difference between the highest and the second highest Enrollment rate (%) in Equatorial Guinea?
Your answer should be very brief. 14.11. What is the difference between the highest and the second highest Enrollment rate (%) in St. Kitts and Nevis?
Provide a succinct answer. 4.51. What is the difference between the highest and the lowest Enrollment rate (%) of Caribbean small states?
Give a very brief answer. 3.73. What is the difference between the highest and the lowest Enrollment rate (%) of Burkina Faso?
Your response must be concise. 23.94. What is the difference between the highest and the lowest Enrollment rate (%) of Equatorial Guinea?
Provide a short and direct response. 19.89. What is the difference between the highest and the lowest Enrollment rate (%) in St. Kitts and Nevis?
Ensure brevity in your answer.  13.67. 